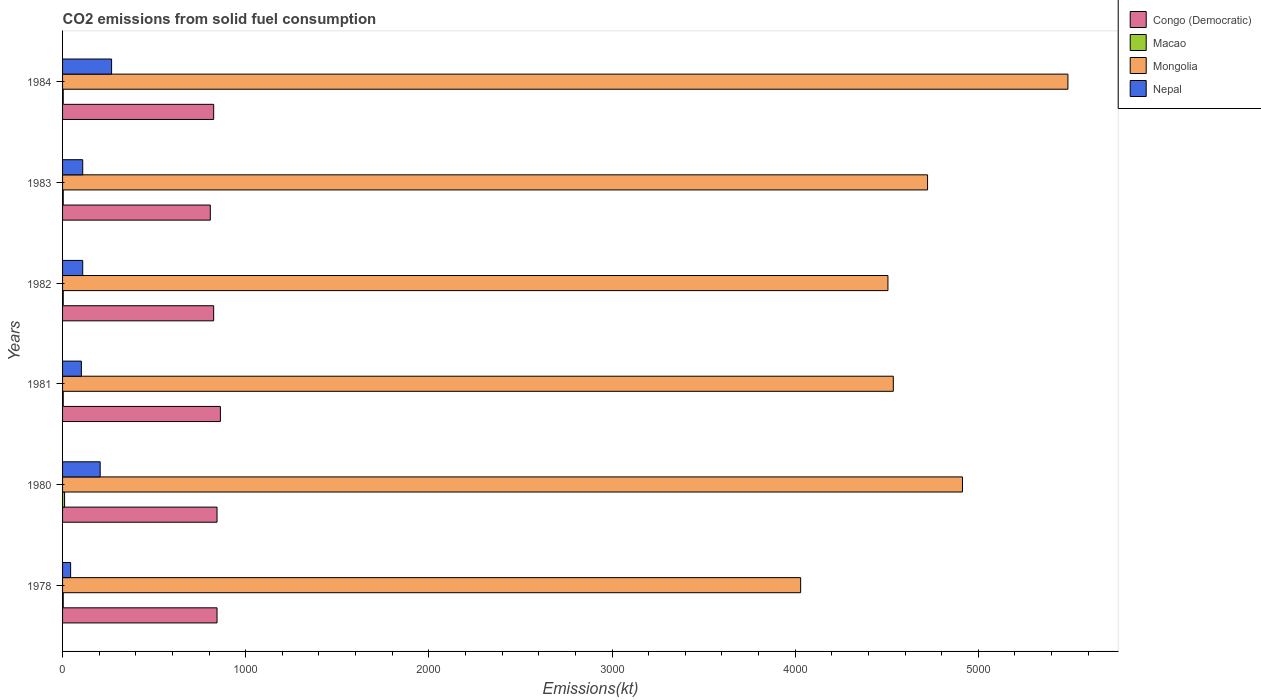Are the number of bars per tick equal to the number of legend labels?
Keep it short and to the point. Yes. Are the number of bars on each tick of the Y-axis equal?
Make the answer very short. Yes. How many bars are there on the 4th tick from the top?
Your answer should be very brief. 4. What is the amount of CO2 emitted in Nepal in 1981?
Keep it short and to the point. 102.68. Across all years, what is the maximum amount of CO2 emitted in Congo (Democratic)?
Keep it short and to the point. 861.75. Across all years, what is the minimum amount of CO2 emitted in Mongolia?
Provide a short and direct response. 4030.03. In which year was the amount of CO2 emitted in Macao minimum?
Ensure brevity in your answer.  1978. What is the total amount of CO2 emitted in Nepal in the graph?
Make the answer very short. 839.74. What is the difference between the amount of CO2 emitted in Mongolia in 1980 and that in 1982?
Provide a short and direct response. 407.04. What is the difference between the amount of CO2 emitted in Nepal in 1980 and the amount of CO2 emitted in Congo (Democratic) in 1984?
Provide a succinct answer. -619.72. What is the average amount of CO2 emitted in Nepal per year?
Provide a short and direct response. 139.96. In the year 1978, what is the difference between the amount of CO2 emitted in Macao and amount of CO2 emitted in Mongolia?
Provide a succinct answer. -4026.37. What is the ratio of the amount of CO2 emitted in Macao in 1982 to that in 1984?
Your answer should be very brief. 1. What is the difference between the highest and the second highest amount of CO2 emitted in Congo (Democratic)?
Offer a terse response. 18.34. What is the difference between the highest and the lowest amount of CO2 emitted in Nepal?
Keep it short and to the point. 223.69. In how many years, is the amount of CO2 emitted in Nepal greater than the average amount of CO2 emitted in Nepal taken over all years?
Keep it short and to the point. 2. Is the sum of the amount of CO2 emitted in Mongolia in 1982 and 1984 greater than the maximum amount of CO2 emitted in Nepal across all years?
Provide a short and direct response. Yes. What does the 3rd bar from the top in 1981 represents?
Your answer should be compact. Macao. What does the 1st bar from the bottom in 1982 represents?
Your answer should be compact. Congo (Democratic). Are all the bars in the graph horizontal?
Keep it short and to the point. Yes. How many years are there in the graph?
Provide a short and direct response. 6. Does the graph contain any zero values?
Offer a very short reply. No. Does the graph contain grids?
Your answer should be compact. No. Where does the legend appear in the graph?
Make the answer very short. Top right. How many legend labels are there?
Ensure brevity in your answer.  4. What is the title of the graph?
Give a very brief answer. CO2 emissions from solid fuel consumption. What is the label or title of the X-axis?
Ensure brevity in your answer.  Emissions(kt). What is the Emissions(kt) in Congo (Democratic) in 1978?
Make the answer very short. 843.41. What is the Emissions(kt) in Macao in 1978?
Keep it short and to the point. 3.67. What is the Emissions(kt) of Mongolia in 1978?
Provide a succinct answer. 4030.03. What is the Emissions(kt) in Nepal in 1978?
Keep it short and to the point. 44. What is the Emissions(kt) of Congo (Democratic) in 1980?
Ensure brevity in your answer.  843.41. What is the Emissions(kt) in Macao in 1980?
Give a very brief answer. 11. What is the Emissions(kt) of Mongolia in 1980?
Offer a terse response. 4913.78. What is the Emissions(kt) of Nepal in 1980?
Ensure brevity in your answer.  205.35. What is the Emissions(kt) in Congo (Democratic) in 1981?
Provide a short and direct response. 861.75. What is the Emissions(kt) of Macao in 1981?
Your answer should be compact. 3.67. What is the Emissions(kt) of Mongolia in 1981?
Make the answer very short. 4536.08. What is the Emissions(kt) in Nepal in 1981?
Ensure brevity in your answer.  102.68. What is the Emissions(kt) of Congo (Democratic) in 1982?
Provide a short and direct response. 825.08. What is the Emissions(kt) in Macao in 1982?
Offer a terse response. 3.67. What is the Emissions(kt) of Mongolia in 1982?
Provide a short and direct response. 4506.74. What is the Emissions(kt) in Nepal in 1982?
Your answer should be very brief. 110.01. What is the Emissions(kt) in Congo (Democratic) in 1983?
Your response must be concise. 806.74. What is the Emissions(kt) in Macao in 1983?
Give a very brief answer. 3.67. What is the Emissions(kt) of Mongolia in 1983?
Offer a terse response. 4723.1. What is the Emissions(kt) in Nepal in 1983?
Provide a succinct answer. 110.01. What is the Emissions(kt) of Congo (Democratic) in 1984?
Provide a short and direct response. 825.08. What is the Emissions(kt) in Macao in 1984?
Provide a short and direct response. 3.67. What is the Emissions(kt) of Mongolia in 1984?
Offer a terse response. 5489.5. What is the Emissions(kt) of Nepal in 1984?
Your answer should be very brief. 267.69. Across all years, what is the maximum Emissions(kt) of Congo (Democratic)?
Offer a very short reply. 861.75. Across all years, what is the maximum Emissions(kt) of Macao?
Make the answer very short. 11. Across all years, what is the maximum Emissions(kt) in Mongolia?
Provide a succinct answer. 5489.5. Across all years, what is the maximum Emissions(kt) of Nepal?
Ensure brevity in your answer.  267.69. Across all years, what is the minimum Emissions(kt) in Congo (Democratic)?
Give a very brief answer. 806.74. Across all years, what is the minimum Emissions(kt) of Macao?
Give a very brief answer. 3.67. Across all years, what is the minimum Emissions(kt) of Mongolia?
Your answer should be compact. 4030.03. Across all years, what is the minimum Emissions(kt) of Nepal?
Give a very brief answer. 44. What is the total Emissions(kt) in Congo (Democratic) in the graph?
Your response must be concise. 5005.45. What is the total Emissions(kt) of Macao in the graph?
Provide a succinct answer. 29.34. What is the total Emissions(kt) of Mongolia in the graph?
Offer a very short reply. 2.82e+04. What is the total Emissions(kt) in Nepal in the graph?
Offer a terse response. 839.74. What is the difference between the Emissions(kt) in Macao in 1978 and that in 1980?
Make the answer very short. -7.33. What is the difference between the Emissions(kt) in Mongolia in 1978 and that in 1980?
Your answer should be compact. -883.75. What is the difference between the Emissions(kt) in Nepal in 1978 and that in 1980?
Provide a succinct answer. -161.35. What is the difference between the Emissions(kt) of Congo (Democratic) in 1978 and that in 1981?
Offer a terse response. -18.34. What is the difference between the Emissions(kt) of Mongolia in 1978 and that in 1981?
Provide a succinct answer. -506.05. What is the difference between the Emissions(kt) in Nepal in 1978 and that in 1981?
Your response must be concise. -58.67. What is the difference between the Emissions(kt) of Congo (Democratic) in 1978 and that in 1982?
Your response must be concise. 18.34. What is the difference between the Emissions(kt) in Macao in 1978 and that in 1982?
Offer a very short reply. 0. What is the difference between the Emissions(kt) in Mongolia in 1978 and that in 1982?
Offer a terse response. -476.71. What is the difference between the Emissions(kt) of Nepal in 1978 and that in 1982?
Keep it short and to the point. -66.01. What is the difference between the Emissions(kt) of Congo (Democratic) in 1978 and that in 1983?
Make the answer very short. 36.67. What is the difference between the Emissions(kt) of Macao in 1978 and that in 1983?
Your answer should be very brief. 0. What is the difference between the Emissions(kt) of Mongolia in 1978 and that in 1983?
Offer a terse response. -693.06. What is the difference between the Emissions(kt) of Nepal in 1978 and that in 1983?
Your answer should be very brief. -66.01. What is the difference between the Emissions(kt) of Congo (Democratic) in 1978 and that in 1984?
Your response must be concise. 18.34. What is the difference between the Emissions(kt) in Mongolia in 1978 and that in 1984?
Offer a very short reply. -1459.47. What is the difference between the Emissions(kt) in Nepal in 1978 and that in 1984?
Your response must be concise. -223.69. What is the difference between the Emissions(kt) of Congo (Democratic) in 1980 and that in 1981?
Offer a very short reply. -18.34. What is the difference between the Emissions(kt) of Macao in 1980 and that in 1981?
Make the answer very short. 7.33. What is the difference between the Emissions(kt) of Mongolia in 1980 and that in 1981?
Keep it short and to the point. 377.7. What is the difference between the Emissions(kt) in Nepal in 1980 and that in 1981?
Your answer should be very brief. 102.68. What is the difference between the Emissions(kt) in Congo (Democratic) in 1980 and that in 1982?
Offer a very short reply. 18.34. What is the difference between the Emissions(kt) of Macao in 1980 and that in 1982?
Your answer should be very brief. 7.33. What is the difference between the Emissions(kt) of Mongolia in 1980 and that in 1982?
Keep it short and to the point. 407.04. What is the difference between the Emissions(kt) in Nepal in 1980 and that in 1982?
Ensure brevity in your answer.  95.34. What is the difference between the Emissions(kt) of Congo (Democratic) in 1980 and that in 1983?
Offer a terse response. 36.67. What is the difference between the Emissions(kt) of Macao in 1980 and that in 1983?
Your response must be concise. 7.33. What is the difference between the Emissions(kt) in Mongolia in 1980 and that in 1983?
Your answer should be very brief. 190.68. What is the difference between the Emissions(kt) of Nepal in 1980 and that in 1983?
Keep it short and to the point. 95.34. What is the difference between the Emissions(kt) of Congo (Democratic) in 1980 and that in 1984?
Ensure brevity in your answer.  18.34. What is the difference between the Emissions(kt) of Macao in 1980 and that in 1984?
Make the answer very short. 7.33. What is the difference between the Emissions(kt) in Mongolia in 1980 and that in 1984?
Keep it short and to the point. -575.72. What is the difference between the Emissions(kt) of Nepal in 1980 and that in 1984?
Your answer should be compact. -62.34. What is the difference between the Emissions(kt) in Congo (Democratic) in 1981 and that in 1982?
Your answer should be very brief. 36.67. What is the difference between the Emissions(kt) of Macao in 1981 and that in 1982?
Make the answer very short. 0. What is the difference between the Emissions(kt) in Mongolia in 1981 and that in 1982?
Provide a short and direct response. 29.34. What is the difference between the Emissions(kt) of Nepal in 1981 and that in 1982?
Give a very brief answer. -7.33. What is the difference between the Emissions(kt) of Congo (Democratic) in 1981 and that in 1983?
Your answer should be compact. 55.01. What is the difference between the Emissions(kt) in Macao in 1981 and that in 1983?
Keep it short and to the point. 0. What is the difference between the Emissions(kt) of Mongolia in 1981 and that in 1983?
Ensure brevity in your answer.  -187.02. What is the difference between the Emissions(kt) in Nepal in 1981 and that in 1983?
Provide a succinct answer. -7.33. What is the difference between the Emissions(kt) in Congo (Democratic) in 1981 and that in 1984?
Provide a succinct answer. 36.67. What is the difference between the Emissions(kt) in Macao in 1981 and that in 1984?
Offer a very short reply. 0. What is the difference between the Emissions(kt) in Mongolia in 1981 and that in 1984?
Keep it short and to the point. -953.42. What is the difference between the Emissions(kt) of Nepal in 1981 and that in 1984?
Offer a very short reply. -165.01. What is the difference between the Emissions(kt) of Congo (Democratic) in 1982 and that in 1983?
Keep it short and to the point. 18.34. What is the difference between the Emissions(kt) in Mongolia in 1982 and that in 1983?
Provide a succinct answer. -216.35. What is the difference between the Emissions(kt) in Congo (Democratic) in 1982 and that in 1984?
Offer a terse response. 0. What is the difference between the Emissions(kt) of Mongolia in 1982 and that in 1984?
Make the answer very short. -982.76. What is the difference between the Emissions(kt) in Nepal in 1982 and that in 1984?
Provide a succinct answer. -157.68. What is the difference between the Emissions(kt) in Congo (Democratic) in 1983 and that in 1984?
Offer a terse response. -18.34. What is the difference between the Emissions(kt) in Mongolia in 1983 and that in 1984?
Your response must be concise. -766.4. What is the difference between the Emissions(kt) of Nepal in 1983 and that in 1984?
Your answer should be very brief. -157.68. What is the difference between the Emissions(kt) of Congo (Democratic) in 1978 and the Emissions(kt) of Macao in 1980?
Your answer should be very brief. 832.41. What is the difference between the Emissions(kt) of Congo (Democratic) in 1978 and the Emissions(kt) of Mongolia in 1980?
Offer a very short reply. -4070.37. What is the difference between the Emissions(kt) of Congo (Democratic) in 1978 and the Emissions(kt) of Nepal in 1980?
Ensure brevity in your answer.  638.06. What is the difference between the Emissions(kt) in Macao in 1978 and the Emissions(kt) in Mongolia in 1980?
Give a very brief answer. -4910.11. What is the difference between the Emissions(kt) in Macao in 1978 and the Emissions(kt) in Nepal in 1980?
Provide a succinct answer. -201.69. What is the difference between the Emissions(kt) of Mongolia in 1978 and the Emissions(kt) of Nepal in 1980?
Your response must be concise. 3824.68. What is the difference between the Emissions(kt) of Congo (Democratic) in 1978 and the Emissions(kt) of Macao in 1981?
Provide a short and direct response. 839.74. What is the difference between the Emissions(kt) in Congo (Democratic) in 1978 and the Emissions(kt) in Mongolia in 1981?
Ensure brevity in your answer.  -3692.67. What is the difference between the Emissions(kt) in Congo (Democratic) in 1978 and the Emissions(kt) in Nepal in 1981?
Offer a very short reply. 740.73. What is the difference between the Emissions(kt) in Macao in 1978 and the Emissions(kt) in Mongolia in 1981?
Offer a very short reply. -4532.41. What is the difference between the Emissions(kt) in Macao in 1978 and the Emissions(kt) in Nepal in 1981?
Offer a terse response. -99.01. What is the difference between the Emissions(kt) of Mongolia in 1978 and the Emissions(kt) of Nepal in 1981?
Give a very brief answer. 3927.36. What is the difference between the Emissions(kt) of Congo (Democratic) in 1978 and the Emissions(kt) of Macao in 1982?
Your response must be concise. 839.74. What is the difference between the Emissions(kt) in Congo (Democratic) in 1978 and the Emissions(kt) in Mongolia in 1982?
Offer a terse response. -3663.33. What is the difference between the Emissions(kt) in Congo (Democratic) in 1978 and the Emissions(kt) in Nepal in 1982?
Provide a short and direct response. 733.4. What is the difference between the Emissions(kt) of Macao in 1978 and the Emissions(kt) of Mongolia in 1982?
Provide a succinct answer. -4503.08. What is the difference between the Emissions(kt) in Macao in 1978 and the Emissions(kt) in Nepal in 1982?
Your answer should be very brief. -106.34. What is the difference between the Emissions(kt) of Mongolia in 1978 and the Emissions(kt) of Nepal in 1982?
Your response must be concise. 3920.02. What is the difference between the Emissions(kt) of Congo (Democratic) in 1978 and the Emissions(kt) of Macao in 1983?
Give a very brief answer. 839.74. What is the difference between the Emissions(kt) of Congo (Democratic) in 1978 and the Emissions(kt) of Mongolia in 1983?
Your answer should be compact. -3879.69. What is the difference between the Emissions(kt) of Congo (Democratic) in 1978 and the Emissions(kt) of Nepal in 1983?
Your answer should be compact. 733.4. What is the difference between the Emissions(kt) of Macao in 1978 and the Emissions(kt) of Mongolia in 1983?
Offer a very short reply. -4719.43. What is the difference between the Emissions(kt) of Macao in 1978 and the Emissions(kt) of Nepal in 1983?
Provide a succinct answer. -106.34. What is the difference between the Emissions(kt) in Mongolia in 1978 and the Emissions(kt) in Nepal in 1983?
Provide a succinct answer. 3920.02. What is the difference between the Emissions(kt) of Congo (Democratic) in 1978 and the Emissions(kt) of Macao in 1984?
Your response must be concise. 839.74. What is the difference between the Emissions(kt) of Congo (Democratic) in 1978 and the Emissions(kt) of Mongolia in 1984?
Your response must be concise. -4646.09. What is the difference between the Emissions(kt) in Congo (Democratic) in 1978 and the Emissions(kt) in Nepal in 1984?
Your answer should be compact. 575.72. What is the difference between the Emissions(kt) in Macao in 1978 and the Emissions(kt) in Mongolia in 1984?
Ensure brevity in your answer.  -5485.83. What is the difference between the Emissions(kt) of Macao in 1978 and the Emissions(kt) of Nepal in 1984?
Make the answer very short. -264.02. What is the difference between the Emissions(kt) in Mongolia in 1978 and the Emissions(kt) in Nepal in 1984?
Your response must be concise. 3762.34. What is the difference between the Emissions(kt) of Congo (Democratic) in 1980 and the Emissions(kt) of Macao in 1981?
Offer a very short reply. 839.74. What is the difference between the Emissions(kt) in Congo (Democratic) in 1980 and the Emissions(kt) in Mongolia in 1981?
Your response must be concise. -3692.67. What is the difference between the Emissions(kt) of Congo (Democratic) in 1980 and the Emissions(kt) of Nepal in 1981?
Give a very brief answer. 740.73. What is the difference between the Emissions(kt) of Macao in 1980 and the Emissions(kt) of Mongolia in 1981?
Your response must be concise. -4525.08. What is the difference between the Emissions(kt) in Macao in 1980 and the Emissions(kt) in Nepal in 1981?
Provide a short and direct response. -91.67. What is the difference between the Emissions(kt) of Mongolia in 1980 and the Emissions(kt) of Nepal in 1981?
Make the answer very short. 4811.1. What is the difference between the Emissions(kt) of Congo (Democratic) in 1980 and the Emissions(kt) of Macao in 1982?
Your response must be concise. 839.74. What is the difference between the Emissions(kt) in Congo (Democratic) in 1980 and the Emissions(kt) in Mongolia in 1982?
Offer a very short reply. -3663.33. What is the difference between the Emissions(kt) of Congo (Democratic) in 1980 and the Emissions(kt) of Nepal in 1982?
Your answer should be compact. 733.4. What is the difference between the Emissions(kt) in Macao in 1980 and the Emissions(kt) in Mongolia in 1982?
Provide a succinct answer. -4495.74. What is the difference between the Emissions(kt) in Macao in 1980 and the Emissions(kt) in Nepal in 1982?
Your answer should be compact. -99.01. What is the difference between the Emissions(kt) in Mongolia in 1980 and the Emissions(kt) in Nepal in 1982?
Give a very brief answer. 4803.77. What is the difference between the Emissions(kt) of Congo (Democratic) in 1980 and the Emissions(kt) of Macao in 1983?
Your answer should be very brief. 839.74. What is the difference between the Emissions(kt) of Congo (Democratic) in 1980 and the Emissions(kt) of Mongolia in 1983?
Provide a succinct answer. -3879.69. What is the difference between the Emissions(kt) in Congo (Democratic) in 1980 and the Emissions(kt) in Nepal in 1983?
Offer a terse response. 733.4. What is the difference between the Emissions(kt) in Macao in 1980 and the Emissions(kt) in Mongolia in 1983?
Your answer should be very brief. -4712.1. What is the difference between the Emissions(kt) in Macao in 1980 and the Emissions(kt) in Nepal in 1983?
Offer a very short reply. -99.01. What is the difference between the Emissions(kt) of Mongolia in 1980 and the Emissions(kt) of Nepal in 1983?
Make the answer very short. 4803.77. What is the difference between the Emissions(kt) in Congo (Democratic) in 1980 and the Emissions(kt) in Macao in 1984?
Give a very brief answer. 839.74. What is the difference between the Emissions(kt) in Congo (Democratic) in 1980 and the Emissions(kt) in Mongolia in 1984?
Offer a terse response. -4646.09. What is the difference between the Emissions(kt) in Congo (Democratic) in 1980 and the Emissions(kt) in Nepal in 1984?
Offer a terse response. 575.72. What is the difference between the Emissions(kt) in Macao in 1980 and the Emissions(kt) in Mongolia in 1984?
Give a very brief answer. -5478.5. What is the difference between the Emissions(kt) of Macao in 1980 and the Emissions(kt) of Nepal in 1984?
Ensure brevity in your answer.  -256.69. What is the difference between the Emissions(kt) in Mongolia in 1980 and the Emissions(kt) in Nepal in 1984?
Offer a terse response. 4646.09. What is the difference between the Emissions(kt) of Congo (Democratic) in 1981 and the Emissions(kt) of Macao in 1982?
Provide a short and direct response. 858.08. What is the difference between the Emissions(kt) in Congo (Democratic) in 1981 and the Emissions(kt) in Mongolia in 1982?
Provide a succinct answer. -3645. What is the difference between the Emissions(kt) of Congo (Democratic) in 1981 and the Emissions(kt) of Nepal in 1982?
Give a very brief answer. 751.74. What is the difference between the Emissions(kt) of Macao in 1981 and the Emissions(kt) of Mongolia in 1982?
Make the answer very short. -4503.08. What is the difference between the Emissions(kt) in Macao in 1981 and the Emissions(kt) in Nepal in 1982?
Your answer should be compact. -106.34. What is the difference between the Emissions(kt) of Mongolia in 1981 and the Emissions(kt) of Nepal in 1982?
Your response must be concise. 4426.07. What is the difference between the Emissions(kt) of Congo (Democratic) in 1981 and the Emissions(kt) of Macao in 1983?
Your answer should be compact. 858.08. What is the difference between the Emissions(kt) in Congo (Democratic) in 1981 and the Emissions(kt) in Mongolia in 1983?
Provide a short and direct response. -3861.35. What is the difference between the Emissions(kt) in Congo (Democratic) in 1981 and the Emissions(kt) in Nepal in 1983?
Provide a short and direct response. 751.74. What is the difference between the Emissions(kt) of Macao in 1981 and the Emissions(kt) of Mongolia in 1983?
Keep it short and to the point. -4719.43. What is the difference between the Emissions(kt) in Macao in 1981 and the Emissions(kt) in Nepal in 1983?
Offer a very short reply. -106.34. What is the difference between the Emissions(kt) in Mongolia in 1981 and the Emissions(kt) in Nepal in 1983?
Keep it short and to the point. 4426.07. What is the difference between the Emissions(kt) of Congo (Democratic) in 1981 and the Emissions(kt) of Macao in 1984?
Offer a very short reply. 858.08. What is the difference between the Emissions(kt) in Congo (Democratic) in 1981 and the Emissions(kt) in Mongolia in 1984?
Your answer should be very brief. -4627.75. What is the difference between the Emissions(kt) in Congo (Democratic) in 1981 and the Emissions(kt) in Nepal in 1984?
Your answer should be very brief. 594.05. What is the difference between the Emissions(kt) of Macao in 1981 and the Emissions(kt) of Mongolia in 1984?
Your answer should be very brief. -5485.83. What is the difference between the Emissions(kt) in Macao in 1981 and the Emissions(kt) in Nepal in 1984?
Your answer should be compact. -264.02. What is the difference between the Emissions(kt) in Mongolia in 1981 and the Emissions(kt) in Nepal in 1984?
Make the answer very short. 4268.39. What is the difference between the Emissions(kt) of Congo (Democratic) in 1982 and the Emissions(kt) of Macao in 1983?
Your answer should be very brief. 821.41. What is the difference between the Emissions(kt) in Congo (Democratic) in 1982 and the Emissions(kt) in Mongolia in 1983?
Your response must be concise. -3898.02. What is the difference between the Emissions(kt) of Congo (Democratic) in 1982 and the Emissions(kt) of Nepal in 1983?
Provide a short and direct response. 715.07. What is the difference between the Emissions(kt) of Macao in 1982 and the Emissions(kt) of Mongolia in 1983?
Your answer should be very brief. -4719.43. What is the difference between the Emissions(kt) of Macao in 1982 and the Emissions(kt) of Nepal in 1983?
Your answer should be very brief. -106.34. What is the difference between the Emissions(kt) in Mongolia in 1982 and the Emissions(kt) in Nepal in 1983?
Offer a terse response. 4396.73. What is the difference between the Emissions(kt) of Congo (Democratic) in 1982 and the Emissions(kt) of Macao in 1984?
Your answer should be compact. 821.41. What is the difference between the Emissions(kt) of Congo (Democratic) in 1982 and the Emissions(kt) of Mongolia in 1984?
Your answer should be very brief. -4664.42. What is the difference between the Emissions(kt) in Congo (Democratic) in 1982 and the Emissions(kt) in Nepal in 1984?
Make the answer very short. 557.38. What is the difference between the Emissions(kt) in Macao in 1982 and the Emissions(kt) in Mongolia in 1984?
Provide a short and direct response. -5485.83. What is the difference between the Emissions(kt) in Macao in 1982 and the Emissions(kt) in Nepal in 1984?
Provide a succinct answer. -264.02. What is the difference between the Emissions(kt) of Mongolia in 1982 and the Emissions(kt) of Nepal in 1984?
Your answer should be compact. 4239.05. What is the difference between the Emissions(kt) in Congo (Democratic) in 1983 and the Emissions(kt) in Macao in 1984?
Your response must be concise. 803.07. What is the difference between the Emissions(kt) in Congo (Democratic) in 1983 and the Emissions(kt) in Mongolia in 1984?
Your answer should be compact. -4682.76. What is the difference between the Emissions(kt) of Congo (Democratic) in 1983 and the Emissions(kt) of Nepal in 1984?
Your answer should be very brief. 539.05. What is the difference between the Emissions(kt) in Macao in 1983 and the Emissions(kt) in Mongolia in 1984?
Provide a short and direct response. -5485.83. What is the difference between the Emissions(kt) in Macao in 1983 and the Emissions(kt) in Nepal in 1984?
Offer a very short reply. -264.02. What is the difference between the Emissions(kt) of Mongolia in 1983 and the Emissions(kt) of Nepal in 1984?
Provide a succinct answer. 4455.4. What is the average Emissions(kt) in Congo (Democratic) per year?
Your answer should be compact. 834.24. What is the average Emissions(kt) of Macao per year?
Offer a terse response. 4.89. What is the average Emissions(kt) in Mongolia per year?
Offer a very short reply. 4699.87. What is the average Emissions(kt) of Nepal per year?
Your answer should be very brief. 139.96. In the year 1978, what is the difference between the Emissions(kt) of Congo (Democratic) and Emissions(kt) of Macao?
Keep it short and to the point. 839.74. In the year 1978, what is the difference between the Emissions(kt) in Congo (Democratic) and Emissions(kt) in Mongolia?
Your answer should be compact. -3186.62. In the year 1978, what is the difference between the Emissions(kt) in Congo (Democratic) and Emissions(kt) in Nepal?
Give a very brief answer. 799.41. In the year 1978, what is the difference between the Emissions(kt) in Macao and Emissions(kt) in Mongolia?
Offer a terse response. -4026.37. In the year 1978, what is the difference between the Emissions(kt) in Macao and Emissions(kt) in Nepal?
Offer a terse response. -40.34. In the year 1978, what is the difference between the Emissions(kt) in Mongolia and Emissions(kt) in Nepal?
Provide a short and direct response. 3986.03. In the year 1980, what is the difference between the Emissions(kt) in Congo (Democratic) and Emissions(kt) in Macao?
Make the answer very short. 832.41. In the year 1980, what is the difference between the Emissions(kt) of Congo (Democratic) and Emissions(kt) of Mongolia?
Ensure brevity in your answer.  -4070.37. In the year 1980, what is the difference between the Emissions(kt) in Congo (Democratic) and Emissions(kt) in Nepal?
Your answer should be compact. 638.06. In the year 1980, what is the difference between the Emissions(kt) of Macao and Emissions(kt) of Mongolia?
Provide a succinct answer. -4902.78. In the year 1980, what is the difference between the Emissions(kt) of Macao and Emissions(kt) of Nepal?
Offer a terse response. -194.35. In the year 1980, what is the difference between the Emissions(kt) of Mongolia and Emissions(kt) of Nepal?
Your response must be concise. 4708.43. In the year 1981, what is the difference between the Emissions(kt) in Congo (Democratic) and Emissions(kt) in Macao?
Keep it short and to the point. 858.08. In the year 1981, what is the difference between the Emissions(kt) in Congo (Democratic) and Emissions(kt) in Mongolia?
Your answer should be very brief. -3674.33. In the year 1981, what is the difference between the Emissions(kt) in Congo (Democratic) and Emissions(kt) in Nepal?
Make the answer very short. 759.07. In the year 1981, what is the difference between the Emissions(kt) of Macao and Emissions(kt) of Mongolia?
Provide a succinct answer. -4532.41. In the year 1981, what is the difference between the Emissions(kt) of Macao and Emissions(kt) of Nepal?
Provide a short and direct response. -99.01. In the year 1981, what is the difference between the Emissions(kt) in Mongolia and Emissions(kt) in Nepal?
Give a very brief answer. 4433.4. In the year 1982, what is the difference between the Emissions(kt) in Congo (Democratic) and Emissions(kt) in Macao?
Ensure brevity in your answer.  821.41. In the year 1982, what is the difference between the Emissions(kt) in Congo (Democratic) and Emissions(kt) in Mongolia?
Offer a very short reply. -3681.67. In the year 1982, what is the difference between the Emissions(kt) in Congo (Democratic) and Emissions(kt) in Nepal?
Give a very brief answer. 715.07. In the year 1982, what is the difference between the Emissions(kt) in Macao and Emissions(kt) in Mongolia?
Give a very brief answer. -4503.08. In the year 1982, what is the difference between the Emissions(kt) of Macao and Emissions(kt) of Nepal?
Your answer should be compact. -106.34. In the year 1982, what is the difference between the Emissions(kt) of Mongolia and Emissions(kt) of Nepal?
Give a very brief answer. 4396.73. In the year 1983, what is the difference between the Emissions(kt) of Congo (Democratic) and Emissions(kt) of Macao?
Your answer should be very brief. 803.07. In the year 1983, what is the difference between the Emissions(kt) in Congo (Democratic) and Emissions(kt) in Mongolia?
Provide a short and direct response. -3916.36. In the year 1983, what is the difference between the Emissions(kt) in Congo (Democratic) and Emissions(kt) in Nepal?
Offer a terse response. 696.73. In the year 1983, what is the difference between the Emissions(kt) in Macao and Emissions(kt) in Mongolia?
Your response must be concise. -4719.43. In the year 1983, what is the difference between the Emissions(kt) of Macao and Emissions(kt) of Nepal?
Provide a succinct answer. -106.34. In the year 1983, what is the difference between the Emissions(kt) in Mongolia and Emissions(kt) in Nepal?
Your answer should be very brief. 4613.09. In the year 1984, what is the difference between the Emissions(kt) in Congo (Democratic) and Emissions(kt) in Macao?
Your response must be concise. 821.41. In the year 1984, what is the difference between the Emissions(kt) of Congo (Democratic) and Emissions(kt) of Mongolia?
Offer a terse response. -4664.42. In the year 1984, what is the difference between the Emissions(kt) in Congo (Democratic) and Emissions(kt) in Nepal?
Offer a terse response. 557.38. In the year 1984, what is the difference between the Emissions(kt) in Macao and Emissions(kt) in Mongolia?
Your response must be concise. -5485.83. In the year 1984, what is the difference between the Emissions(kt) in Macao and Emissions(kt) in Nepal?
Give a very brief answer. -264.02. In the year 1984, what is the difference between the Emissions(kt) in Mongolia and Emissions(kt) in Nepal?
Give a very brief answer. 5221.81. What is the ratio of the Emissions(kt) in Congo (Democratic) in 1978 to that in 1980?
Your response must be concise. 1. What is the ratio of the Emissions(kt) of Macao in 1978 to that in 1980?
Your answer should be compact. 0.33. What is the ratio of the Emissions(kt) of Mongolia in 1978 to that in 1980?
Provide a succinct answer. 0.82. What is the ratio of the Emissions(kt) of Nepal in 1978 to that in 1980?
Give a very brief answer. 0.21. What is the ratio of the Emissions(kt) in Congo (Democratic) in 1978 to that in 1981?
Make the answer very short. 0.98. What is the ratio of the Emissions(kt) of Mongolia in 1978 to that in 1981?
Your answer should be very brief. 0.89. What is the ratio of the Emissions(kt) of Nepal in 1978 to that in 1981?
Your answer should be very brief. 0.43. What is the ratio of the Emissions(kt) of Congo (Democratic) in 1978 to that in 1982?
Offer a terse response. 1.02. What is the ratio of the Emissions(kt) of Mongolia in 1978 to that in 1982?
Make the answer very short. 0.89. What is the ratio of the Emissions(kt) of Nepal in 1978 to that in 1982?
Give a very brief answer. 0.4. What is the ratio of the Emissions(kt) of Congo (Democratic) in 1978 to that in 1983?
Provide a succinct answer. 1.05. What is the ratio of the Emissions(kt) of Macao in 1978 to that in 1983?
Keep it short and to the point. 1. What is the ratio of the Emissions(kt) of Mongolia in 1978 to that in 1983?
Provide a succinct answer. 0.85. What is the ratio of the Emissions(kt) of Nepal in 1978 to that in 1983?
Your answer should be very brief. 0.4. What is the ratio of the Emissions(kt) in Congo (Democratic) in 1978 to that in 1984?
Ensure brevity in your answer.  1.02. What is the ratio of the Emissions(kt) in Macao in 1978 to that in 1984?
Provide a short and direct response. 1. What is the ratio of the Emissions(kt) of Mongolia in 1978 to that in 1984?
Keep it short and to the point. 0.73. What is the ratio of the Emissions(kt) of Nepal in 1978 to that in 1984?
Offer a terse response. 0.16. What is the ratio of the Emissions(kt) of Congo (Democratic) in 1980 to that in 1981?
Your answer should be very brief. 0.98. What is the ratio of the Emissions(kt) of Macao in 1980 to that in 1981?
Give a very brief answer. 3. What is the ratio of the Emissions(kt) in Mongolia in 1980 to that in 1981?
Provide a succinct answer. 1.08. What is the ratio of the Emissions(kt) of Congo (Democratic) in 1980 to that in 1982?
Ensure brevity in your answer.  1.02. What is the ratio of the Emissions(kt) in Mongolia in 1980 to that in 1982?
Your response must be concise. 1.09. What is the ratio of the Emissions(kt) of Nepal in 1980 to that in 1982?
Ensure brevity in your answer.  1.87. What is the ratio of the Emissions(kt) in Congo (Democratic) in 1980 to that in 1983?
Keep it short and to the point. 1.05. What is the ratio of the Emissions(kt) of Mongolia in 1980 to that in 1983?
Ensure brevity in your answer.  1.04. What is the ratio of the Emissions(kt) in Nepal in 1980 to that in 1983?
Give a very brief answer. 1.87. What is the ratio of the Emissions(kt) in Congo (Democratic) in 1980 to that in 1984?
Your answer should be very brief. 1.02. What is the ratio of the Emissions(kt) of Mongolia in 1980 to that in 1984?
Offer a very short reply. 0.9. What is the ratio of the Emissions(kt) of Nepal in 1980 to that in 1984?
Keep it short and to the point. 0.77. What is the ratio of the Emissions(kt) in Congo (Democratic) in 1981 to that in 1982?
Offer a very short reply. 1.04. What is the ratio of the Emissions(kt) of Macao in 1981 to that in 1982?
Your answer should be compact. 1. What is the ratio of the Emissions(kt) in Mongolia in 1981 to that in 1982?
Give a very brief answer. 1.01. What is the ratio of the Emissions(kt) in Congo (Democratic) in 1981 to that in 1983?
Provide a short and direct response. 1.07. What is the ratio of the Emissions(kt) in Mongolia in 1981 to that in 1983?
Provide a succinct answer. 0.96. What is the ratio of the Emissions(kt) of Congo (Democratic) in 1981 to that in 1984?
Your response must be concise. 1.04. What is the ratio of the Emissions(kt) of Mongolia in 1981 to that in 1984?
Offer a very short reply. 0.83. What is the ratio of the Emissions(kt) in Nepal in 1981 to that in 1984?
Provide a short and direct response. 0.38. What is the ratio of the Emissions(kt) of Congo (Democratic) in 1982 to that in 1983?
Offer a terse response. 1.02. What is the ratio of the Emissions(kt) of Mongolia in 1982 to that in 1983?
Offer a terse response. 0.95. What is the ratio of the Emissions(kt) of Nepal in 1982 to that in 1983?
Your answer should be very brief. 1. What is the ratio of the Emissions(kt) of Congo (Democratic) in 1982 to that in 1984?
Provide a short and direct response. 1. What is the ratio of the Emissions(kt) of Macao in 1982 to that in 1984?
Offer a very short reply. 1. What is the ratio of the Emissions(kt) in Mongolia in 1982 to that in 1984?
Make the answer very short. 0.82. What is the ratio of the Emissions(kt) in Nepal in 1982 to that in 1984?
Keep it short and to the point. 0.41. What is the ratio of the Emissions(kt) in Congo (Democratic) in 1983 to that in 1984?
Give a very brief answer. 0.98. What is the ratio of the Emissions(kt) of Mongolia in 1983 to that in 1984?
Your answer should be very brief. 0.86. What is the ratio of the Emissions(kt) in Nepal in 1983 to that in 1984?
Keep it short and to the point. 0.41. What is the difference between the highest and the second highest Emissions(kt) of Congo (Democratic)?
Offer a very short reply. 18.34. What is the difference between the highest and the second highest Emissions(kt) of Macao?
Keep it short and to the point. 7.33. What is the difference between the highest and the second highest Emissions(kt) of Mongolia?
Give a very brief answer. 575.72. What is the difference between the highest and the second highest Emissions(kt) of Nepal?
Ensure brevity in your answer.  62.34. What is the difference between the highest and the lowest Emissions(kt) of Congo (Democratic)?
Ensure brevity in your answer.  55.01. What is the difference between the highest and the lowest Emissions(kt) of Macao?
Your response must be concise. 7.33. What is the difference between the highest and the lowest Emissions(kt) of Mongolia?
Offer a very short reply. 1459.47. What is the difference between the highest and the lowest Emissions(kt) of Nepal?
Offer a terse response. 223.69. 